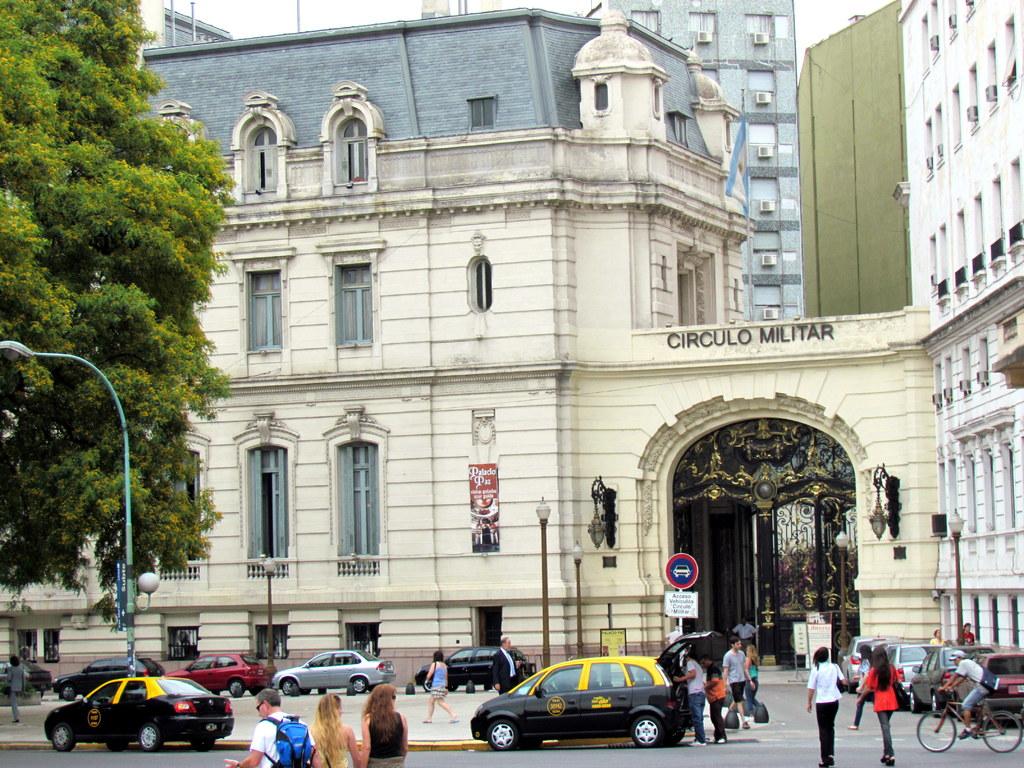What is the name of the building on the arch?
Your answer should be very brief. Circulo militar. 